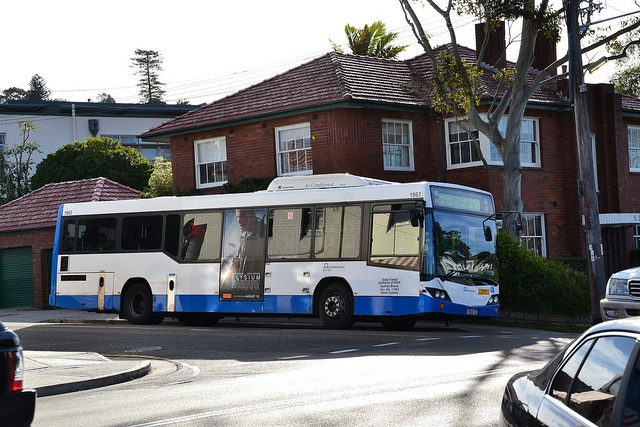Describe the objects in this image and their specific colors. I can see bus in white, black, lightgray, darkgray, and gray tones, car in white, black, lightgray, gray, and darkgray tones, car in white, black, navy, lightgray, and darkgray tones, car in white, gray, black, and darkgray tones, and truck in white, gray, black, and darkgray tones in this image. 